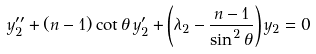Convert formula to latex. <formula><loc_0><loc_0><loc_500><loc_500>y _ { 2 } ^ { \prime \prime } + ( n - 1 ) \cot \theta \, y _ { 2 } ^ { \prime } + \left ( \lambda _ { 2 } - \frac { n - 1 } { \sin ^ { 2 } \theta } \right ) y _ { 2 } = 0</formula> 